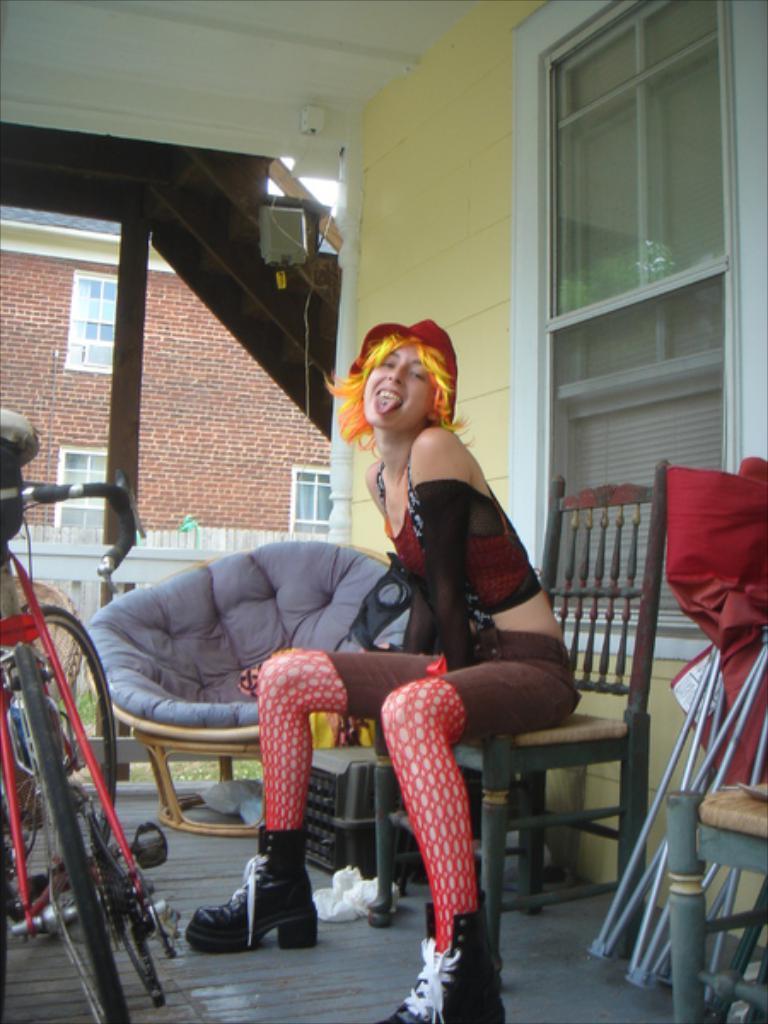Describe this image in one or two sentences. In this picture there is a girl who is sitting on the chair at the right side of the image and there is a bicycle which is placed at the left side of the image and there is one more chair behind the girl in the image, there is a house in the background of the image and a staircase at the left side of the image, there is an umbrella at the right side of the image, the girl is seems to be posing in front direction. 